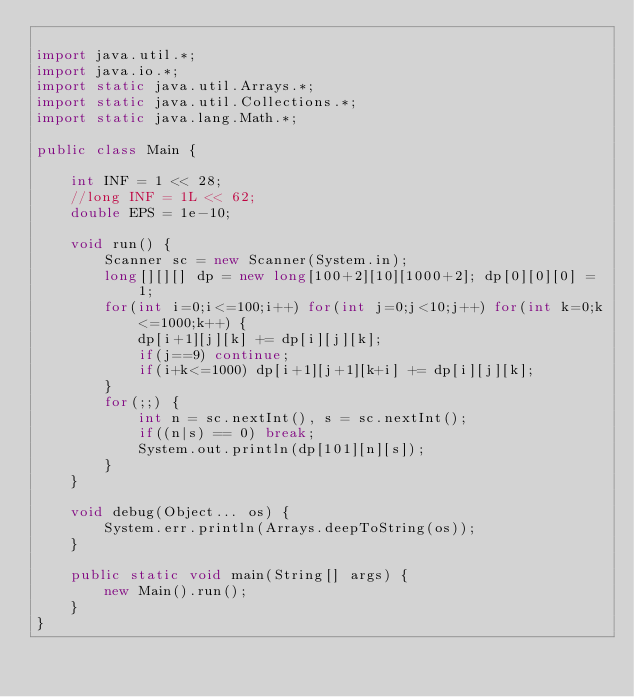Convert code to text. <code><loc_0><loc_0><loc_500><loc_500><_Java_>
import java.util.*;
import java.io.*;
import static java.util.Arrays.*;
import static java.util.Collections.*;
import static java.lang.Math.*;

public class Main {

	int INF = 1 << 28;
	//long INF = 1L << 62;
	double EPS = 1e-10;

	void run() {
		Scanner sc = new Scanner(System.in);
		long[][][] dp = new long[100+2][10][1000+2]; dp[0][0][0] = 1;
		for(int i=0;i<=100;i++) for(int j=0;j<10;j++) for(int k=0;k<=1000;k++) {
			dp[i+1][j][k] += dp[i][j][k];
			if(j==9) continue;
			if(i+k<=1000) dp[i+1][j+1][k+i] += dp[i][j][k];
		}
		for(;;) {
			int n = sc.nextInt(), s = sc.nextInt();
			if((n|s) == 0) break;
			System.out.println(dp[101][n][s]);
		}
	}

	void debug(Object... os) {
		System.err.println(Arrays.deepToString(os));
	}

	public static void main(String[] args) {
		new Main().run();
	}
}</code> 